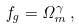Convert formula to latex. <formula><loc_0><loc_0><loc_500><loc_500>f _ { g } = \Omega _ { m } ^ { \gamma } \, ,</formula> 